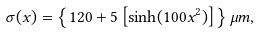Convert formula to latex. <formula><loc_0><loc_0><loc_500><loc_500>\sigma ( x ) = \left \{ 1 2 0 + 5 \left [ \sinh ( 1 0 0 x ^ { 2 } ) \right ] \right \} \mu m ,</formula> 